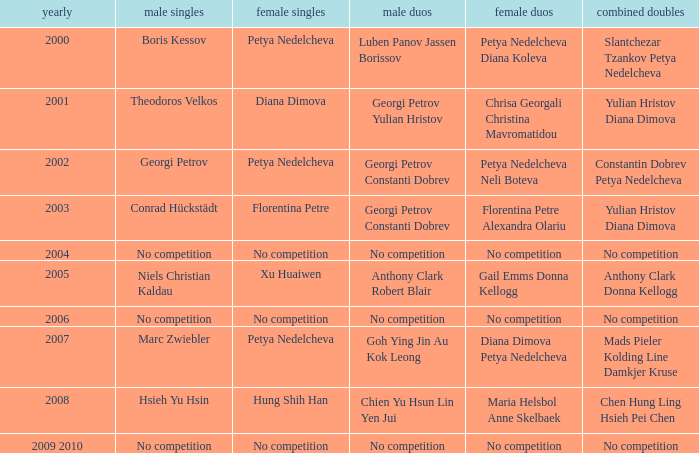What is the year when Conrad Hückstädt won Men's Single? 2003.0. 